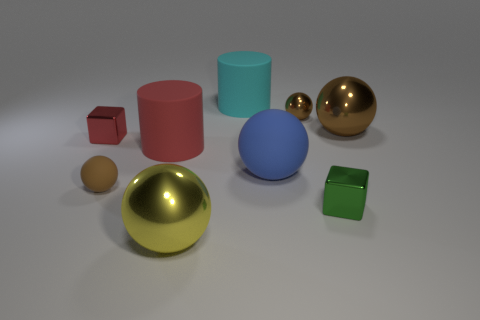Subtract all purple cylinders. How many brown spheres are left? 3 Subtract all large blue balls. How many balls are left? 4 Subtract all blue balls. How many balls are left? 4 Add 1 brown objects. How many objects exist? 10 Subtract all cubes. How many objects are left? 7 Subtract all red cylinders. Subtract all cyan blocks. How many cylinders are left? 1 Subtract all tiny red cubes. Subtract all brown rubber spheres. How many objects are left? 7 Add 4 large yellow objects. How many large yellow objects are left? 5 Add 4 metal things. How many metal things exist? 9 Subtract 0 red balls. How many objects are left? 9 